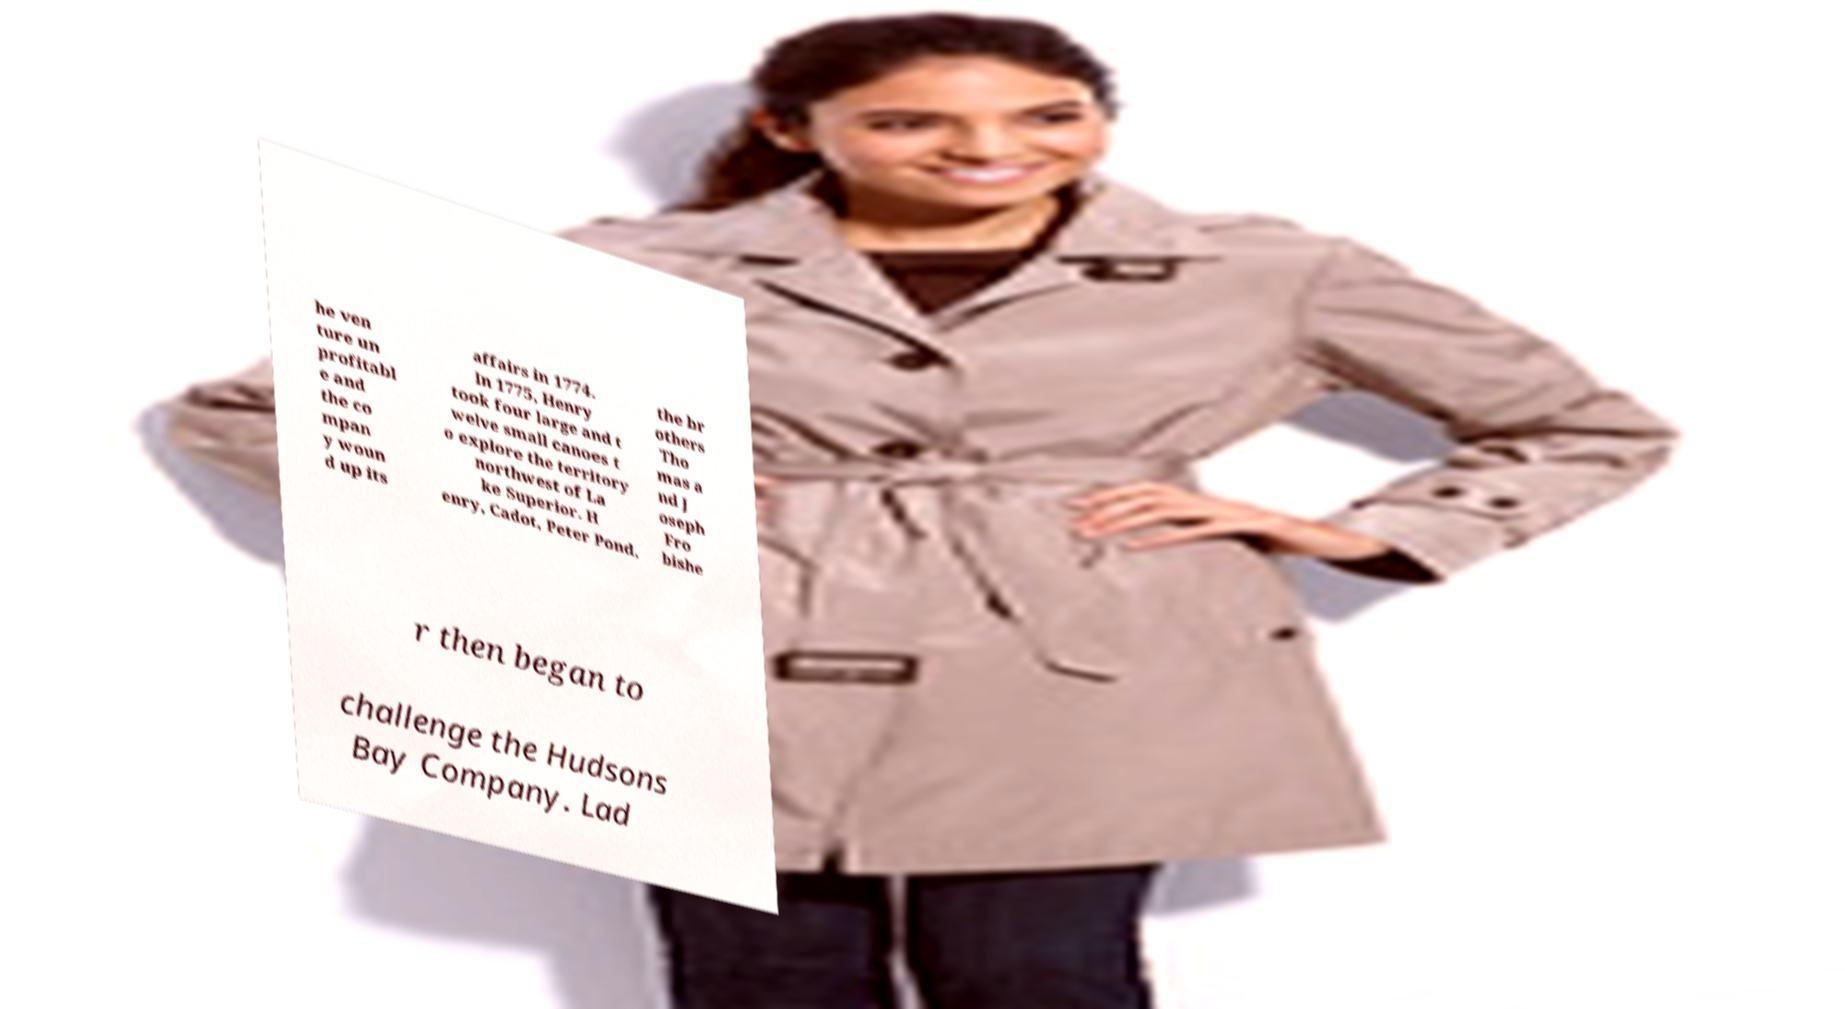Can you read and provide the text displayed in the image?This photo seems to have some interesting text. Can you extract and type it out for me? he ven ture un profitabl e and the co mpan y woun d up its affairs in 1774. In 1775, Henry took four large and t welve small canoes t o explore the territory northwest of La ke Superior. H enry, Cadot, Peter Pond, the br others Tho mas a nd J oseph Fro bishe r then began to challenge the Hudsons Bay Company. Lad 